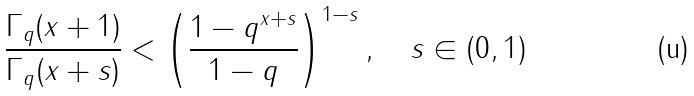<formula> <loc_0><loc_0><loc_500><loc_500>\frac { \Gamma _ { q } ( x + 1 ) } { \Gamma _ { q } ( x + s ) } < \left ( \frac { 1 - q ^ { x + s } } { 1 - q } \right ) ^ { 1 - s } , \quad s \in ( 0 , 1 )</formula> 